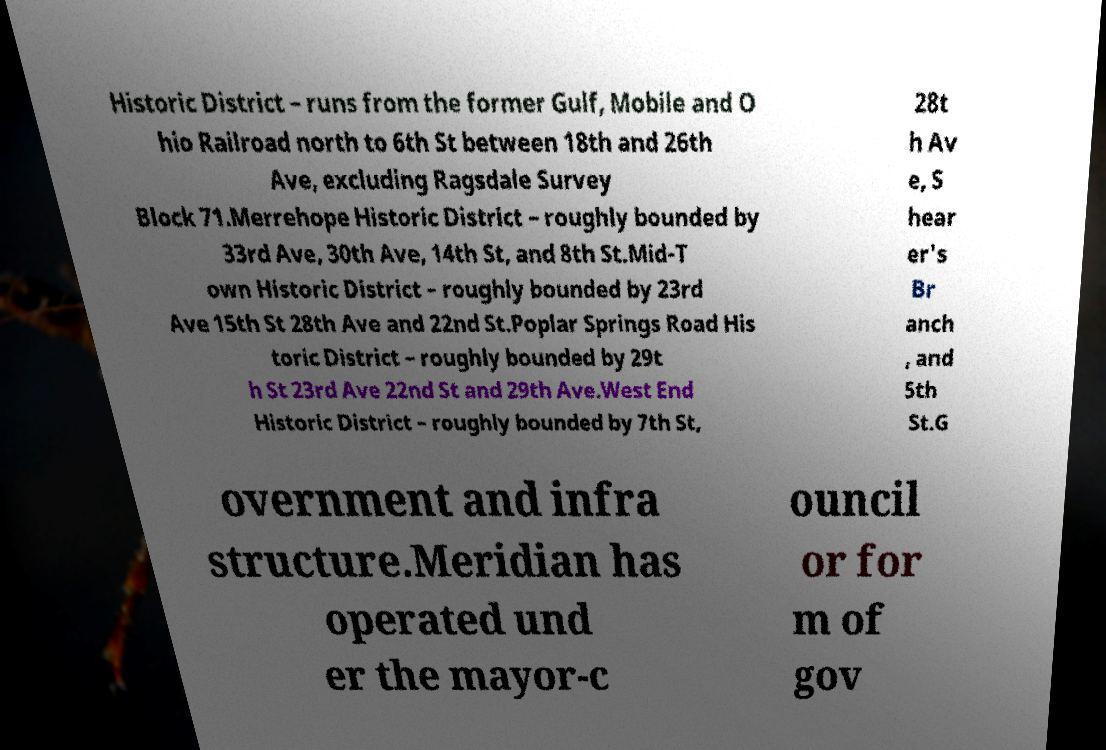I need the written content from this picture converted into text. Can you do that? Historic District – runs from the former Gulf, Mobile and O hio Railroad north to 6th St between 18th and 26th Ave, excluding Ragsdale Survey Block 71.Merrehope Historic District – roughly bounded by 33rd Ave, 30th Ave, 14th St, and 8th St.Mid-T own Historic District – roughly bounded by 23rd Ave 15th St 28th Ave and 22nd St.Poplar Springs Road His toric District – roughly bounded by 29t h St 23rd Ave 22nd St and 29th Ave.West End Historic District – roughly bounded by 7th St, 28t h Av e, S hear er's Br anch , and 5th St.G overnment and infra structure.Meridian has operated und er the mayor-c ouncil or for m of gov 